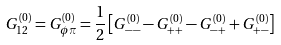Convert formula to latex. <formula><loc_0><loc_0><loc_500><loc_500>G ^ { ( 0 ) } _ { 1 2 } = G ^ { ( 0 ) } _ { \phi \pi } = \frac { 1 } { 2 } \left [ G ^ { ( 0 ) } _ { - - } - G ^ { ( 0 ) } _ { + + } - G ^ { ( 0 ) } _ { - + } + G ^ { ( 0 ) } _ { + - } \right ]</formula> 